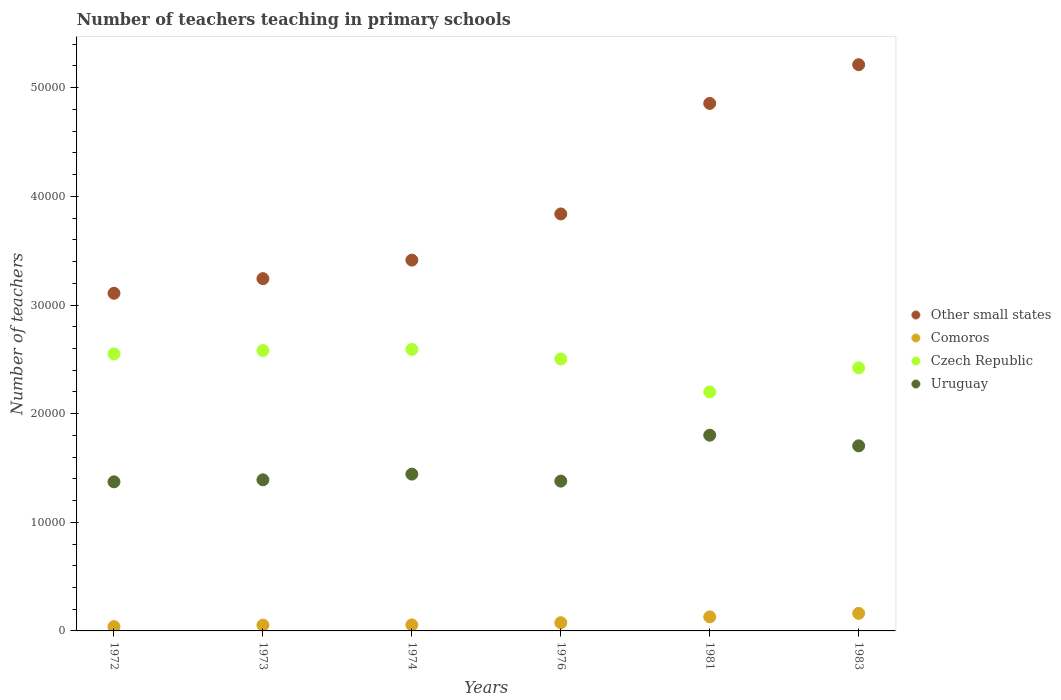Is the number of dotlines equal to the number of legend labels?
Offer a very short reply. Yes. What is the number of teachers teaching in primary schools in Other small states in 1972?
Give a very brief answer. 3.11e+04. Across all years, what is the maximum number of teachers teaching in primary schools in Comoros?
Make the answer very short. 1617. Across all years, what is the minimum number of teachers teaching in primary schools in Czech Republic?
Your answer should be compact. 2.20e+04. In which year was the number of teachers teaching in primary schools in Uruguay maximum?
Offer a very short reply. 1981. In which year was the number of teachers teaching in primary schools in Comoros minimum?
Your response must be concise. 1972. What is the total number of teachers teaching in primary schools in Comoros in the graph?
Your answer should be compact. 5148. What is the difference between the number of teachers teaching in primary schools in Comoros in 1973 and that in 1983?
Give a very brief answer. -1084. What is the difference between the number of teachers teaching in primary schools in Uruguay in 1972 and the number of teachers teaching in primary schools in Comoros in 1976?
Ensure brevity in your answer.  1.30e+04. What is the average number of teachers teaching in primary schools in Comoros per year?
Your response must be concise. 858. In the year 1972, what is the difference between the number of teachers teaching in primary schools in Other small states and number of teachers teaching in primary schools in Czech Republic?
Keep it short and to the point. 5582.75. In how many years, is the number of teachers teaching in primary schools in Uruguay greater than 36000?
Provide a succinct answer. 0. What is the ratio of the number of teachers teaching in primary schools in Comoros in 1976 to that in 1981?
Your answer should be very brief. 0.59. Is the number of teachers teaching in primary schools in Czech Republic in 1972 less than that in 1973?
Keep it short and to the point. Yes. Is the difference between the number of teachers teaching in primary schools in Other small states in 1972 and 1981 greater than the difference between the number of teachers teaching in primary schools in Czech Republic in 1972 and 1981?
Offer a very short reply. No. What is the difference between the highest and the second highest number of teachers teaching in primary schools in Other small states?
Make the answer very short. 3565.71. What is the difference between the highest and the lowest number of teachers teaching in primary schools in Czech Republic?
Your response must be concise. 3914. In how many years, is the number of teachers teaching in primary schools in Other small states greater than the average number of teachers teaching in primary schools in Other small states taken over all years?
Give a very brief answer. 2. Is the sum of the number of teachers teaching in primary schools in Uruguay in 1976 and 1983 greater than the maximum number of teachers teaching in primary schools in Other small states across all years?
Provide a succinct answer. No. Is it the case that in every year, the sum of the number of teachers teaching in primary schools in Czech Republic and number of teachers teaching in primary schools in Other small states  is greater than the number of teachers teaching in primary schools in Uruguay?
Ensure brevity in your answer.  Yes. Is the number of teachers teaching in primary schools in Comoros strictly greater than the number of teachers teaching in primary schools in Other small states over the years?
Offer a very short reply. No. Is the number of teachers teaching in primary schools in Comoros strictly less than the number of teachers teaching in primary schools in Czech Republic over the years?
Offer a very short reply. Yes. Are the values on the major ticks of Y-axis written in scientific E-notation?
Keep it short and to the point. No. Does the graph contain grids?
Keep it short and to the point. No. How many legend labels are there?
Offer a very short reply. 4. What is the title of the graph?
Your response must be concise. Number of teachers teaching in primary schools. Does "Cyprus" appear as one of the legend labels in the graph?
Keep it short and to the point. No. What is the label or title of the Y-axis?
Give a very brief answer. Number of teachers. What is the Number of teachers of Other small states in 1972?
Keep it short and to the point. 3.11e+04. What is the Number of teachers of Comoros in 1972?
Ensure brevity in your answer.  396. What is the Number of teachers of Czech Republic in 1972?
Provide a succinct answer. 2.55e+04. What is the Number of teachers of Uruguay in 1972?
Your answer should be compact. 1.37e+04. What is the Number of teachers in Other small states in 1973?
Keep it short and to the point. 3.24e+04. What is the Number of teachers in Comoros in 1973?
Give a very brief answer. 533. What is the Number of teachers in Czech Republic in 1973?
Offer a terse response. 2.58e+04. What is the Number of teachers in Uruguay in 1973?
Provide a short and direct response. 1.39e+04. What is the Number of teachers in Other small states in 1974?
Your answer should be very brief. 3.41e+04. What is the Number of teachers of Comoros in 1974?
Provide a succinct answer. 554. What is the Number of teachers of Czech Republic in 1974?
Offer a terse response. 2.59e+04. What is the Number of teachers of Uruguay in 1974?
Provide a succinct answer. 1.44e+04. What is the Number of teachers of Other small states in 1976?
Keep it short and to the point. 3.84e+04. What is the Number of teachers in Comoros in 1976?
Your response must be concise. 756. What is the Number of teachers of Czech Republic in 1976?
Offer a terse response. 2.50e+04. What is the Number of teachers in Uruguay in 1976?
Provide a succinct answer. 1.38e+04. What is the Number of teachers in Other small states in 1981?
Offer a very short reply. 4.86e+04. What is the Number of teachers in Comoros in 1981?
Provide a short and direct response. 1292. What is the Number of teachers in Czech Republic in 1981?
Give a very brief answer. 2.20e+04. What is the Number of teachers of Uruguay in 1981?
Offer a very short reply. 1.80e+04. What is the Number of teachers of Other small states in 1983?
Give a very brief answer. 5.21e+04. What is the Number of teachers of Comoros in 1983?
Ensure brevity in your answer.  1617. What is the Number of teachers of Czech Republic in 1983?
Provide a succinct answer. 2.42e+04. What is the Number of teachers in Uruguay in 1983?
Ensure brevity in your answer.  1.70e+04. Across all years, what is the maximum Number of teachers in Other small states?
Ensure brevity in your answer.  5.21e+04. Across all years, what is the maximum Number of teachers in Comoros?
Provide a short and direct response. 1617. Across all years, what is the maximum Number of teachers of Czech Republic?
Your answer should be compact. 2.59e+04. Across all years, what is the maximum Number of teachers in Uruguay?
Offer a very short reply. 1.80e+04. Across all years, what is the minimum Number of teachers of Other small states?
Your answer should be compact. 3.11e+04. Across all years, what is the minimum Number of teachers in Comoros?
Provide a succinct answer. 396. Across all years, what is the minimum Number of teachers in Czech Republic?
Offer a very short reply. 2.20e+04. Across all years, what is the minimum Number of teachers of Uruguay?
Keep it short and to the point. 1.37e+04. What is the total Number of teachers of Other small states in the graph?
Offer a very short reply. 2.37e+05. What is the total Number of teachers of Comoros in the graph?
Provide a short and direct response. 5148. What is the total Number of teachers of Czech Republic in the graph?
Offer a terse response. 1.48e+05. What is the total Number of teachers of Uruguay in the graph?
Offer a terse response. 9.09e+04. What is the difference between the Number of teachers of Other small states in 1972 and that in 1973?
Ensure brevity in your answer.  -1344.78. What is the difference between the Number of teachers in Comoros in 1972 and that in 1973?
Give a very brief answer. -137. What is the difference between the Number of teachers of Czech Republic in 1972 and that in 1973?
Make the answer very short. -311. What is the difference between the Number of teachers in Uruguay in 1972 and that in 1973?
Ensure brevity in your answer.  -184. What is the difference between the Number of teachers in Other small states in 1972 and that in 1974?
Give a very brief answer. -3051.4. What is the difference between the Number of teachers in Comoros in 1972 and that in 1974?
Provide a succinct answer. -158. What is the difference between the Number of teachers in Czech Republic in 1972 and that in 1974?
Offer a very short reply. -415. What is the difference between the Number of teachers of Uruguay in 1972 and that in 1974?
Your answer should be very brief. -710. What is the difference between the Number of teachers in Other small states in 1972 and that in 1976?
Your answer should be compact. -7301.05. What is the difference between the Number of teachers of Comoros in 1972 and that in 1976?
Offer a terse response. -360. What is the difference between the Number of teachers of Czech Republic in 1972 and that in 1976?
Provide a short and direct response. 466. What is the difference between the Number of teachers in Uruguay in 1972 and that in 1976?
Your answer should be compact. -64. What is the difference between the Number of teachers of Other small states in 1972 and that in 1981?
Offer a terse response. -1.75e+04. What is the difference between the Number of teachers of Comoros in 1972 and that in 1981?
Provide a short and direct response. -896. What is the difference between the Number of teachers of Czech Republic in 1972 and that in 1981?
Provide a succinct answer. 3499. What is the difference between the Number of teachers in Uruguay in 1972 and that in 1981?
Give a very brief answer. -4293. What is the difference between the Number of teachers of Other small states in 1972 and that in 1983?
Make the answer very short. -2.10e+04. What is the difference between the Number of teachers in Comoros in 1972 and that in 1983?
Your response must be concise. -1221. What is the difference between the Number of teachers in Czech Republic in 1972 and that in 1983?
Provide a succinct answer. 1282. What is the difference between the Number of teachers in Uruguay in 1972 and that in 1983?
Keep it short and to the point. -3312. What is the difference between the Number of teachers in Other small states in 1973 and that in 1974?
Offer a terse response. -1706.62. What is the difference between the Number of teachers of Comoros in 1973 and that in 1974?
Offer a very short reply. -21. What is the difference between the Number of teachers of Czech Republic in 1973 and that in 1974?
Offer a terse response. -104. What is the difference between the Number of teachers of Uruguay in 1973 and that in 1974?
Your answer should be very brief. -526. What is the difference between the Number of teachers of Other small states in 1973 and that in 1976?
Your answer should be very brief. -5956.27. What is the difference between the Number of teachers of Comoros in 1973 and that in 1976?
Offer a terse response. -223. What is the difference between the Number of teachers in Czech Republic in 1973 and that in 1976?
Your answer should be compact. 777. What is the difference between the Number of teachers in Uruguay in 1973 and that in 1976?
Provide a succinct answer. 120. What is the difference between the Number of teachers in Other small states in 1973 and that in 1981?
Provide a succinct answer. -1.61e+04. What is the difference between the Number of teachers in Comoros in 1973 and that in 1981?
Your answer should be very brief. -759. What is the difference between the Number of teachers of Czech Republic in 1973 and that in 1981?
Your response must be concise. 3810. What is the difference between the Number of teachers in Uruguay in 1973 and that in 1981?
Provide a succinct answer. -4109. What is the difference between the Number of teachers in Other small states in 1973 and that in 1983?
Offer a terse response. -1.97e+04. What is the difference between the Number of teachers of Comoros in 1973 and that in 1983?
Your answer should be compact. -1084. What is the difference between the Number of teachers of Czech Republic in 1973 and that in 1983?
Your answer should be compact. 1593. What is the difference between the Number of teachers of Uruguay in 1973 and that in 1983?
Keep it short and to the point. -3128. What is the difference between the Number of teachers in Other small states in 1974 and that in 1976?
Give a very brief answer. -4249.65. What is the difference between the Number of teachers of Comoros in 1974 and that in 1976?
Your answer should be compact. -202. What is the difference between the Number of teachers in Czech Republic in 1974 and that in 1976?
Offer a very short reply. 881. What is the difference between the Number of teachers of Uruguay in 1974 and that in 1976?
Give a very brief answer. 646. What is the difference between the Number of teachers of Other small states in 1974 and that in 1981?
Offer a terse response. -1.44e+04. What is the difference between the Number of teachers of Comoros in 1974 and that in 1981?
Offer a very short reply. -738. What is the difference between the Number of teachers of Czech Republic in 1974 and that in 1981?
Give a very brief answer. 3914. What is the difference between the Number of teachers of Uruguay in 1974 and that in 1981?
Offer a terse response. -3583. What is the difference between the Number of teachers of Other small states in 1974 and that in 1983?
Offer a very short reply. -1.80e+04. What is the difference between the Number of teachers in Comoros in 1974 and that in 1983?
Provide a short and direct response. -1063. What is the difference between the Number of teachers in Czech Republic in 1974 and that in 1983?
Offer a very short reply. 1697. What is the difference between the Number of teachers in Uruguay in 1974 and that in 1983?
Offer a very short reply. -2602. What is the difference between the Number of teachers in Other small states in 1976 and that in 1981?
Offer a terse response. -1.02e+04. What is the difference between the Number of teachers of Comoros in 1976 and that in 1981?
Give a very brief answer. -536. What is the difference between the Number of teachers in Czech Republic in 1976 and that in 1981?
Provide a short and direct response. 3033. What is the difference between the Number of teachers in Uruguay in 1976 and that in 1981?
Make the answer very short. -4229. What is the difference between the Number of teachers in Other small states in 1976 and that in 1983?
Keep it short and to the point. -1.37e+04. What is the difference between the Number of teachers of Comoros in 1976 and that in 1983?
Keep it short and to the point. -861. What is the difference between the Number of teachers of Czech Republic in 1976 and that in 1983?
Keep it short and to the point. 816. What is the difference between the Number of teachers of Uruguay in 1976 and that in 1983?
Provide a succinct answer. -3248. What is the difference between the Number of teachers of Other small states in 1981 and that in 1983?
Offer a terse response. -3565.71. What is the difference between the Number of teachers of Comoros in 1981 and that in 1983?
Give a very brief answer. -325. What is the difference between the Number of teachers of Czech Republic in 1981 and that in 1983?
Offer a very short reply. -2217. What is the difference between the Number of teachers of Uruguay in 1981 and that in 1983?
Provide a short and direct response. 981. What is the difference between the Number of teachers of Other small states in 1972 and the Number of teachers of Comoros in 1973?
Give a very brief answer. 3.05e+04. What is the difference between the Number of teachers in Other small states in 1972 and the Number of teachers in Czech Republic in 1973?
Give a very brief answer. 5271.75. What is the difference between the Number of teachers of Other small states in 1972 and the Number of teachers of Uruguay in 1973?
Keep it short and to the point. 1.72e+04. What is the difference between the Number of teachers in Comoros in 1972 and the Number of teachers in Czech Republic in 1973?
Your answer should be very brief. -2.54e+04. What is the difference between the Number of teachers in Comoros in 1972 and the Number of teachers in Uruguay in 1973?
Your answer should be compact. -1.35e+04. What is the difference between the Number of teachers in Czech Republic in 1972 and the Number of teachers in Uruguay in 1973?
Offer a very short reply. 1.16e+04. What is the difference between the Number of teachers of Other small states in 1972 and the Number of teachers of Comoros in 1974?
Offer a very short reply. 3.05e+04. What is the difference between the Number of teachers of Other small states in 1972 and the Number of teachers of Czech Republic in 1974?
Your response must be concise. 5167.75. What is the difference between the Number of teachers of Other small states in 1972 and the Number of teachers of Uruguay in 1974?
Your answer should be compact. 1.66e+04. What is the difference between the Number of teachers in Comoros in 1972 and the Number of teachers in Czech Republic in 1974?
Provide a succinct answer. -2.55e+04. What is the difference between the Number of teachers in Comoros in 1972 and the Number of teachers in Uruguay in 1974?
Your answer should be compact. -1.40e+04. What is the difference between the Number of teachers of Czech Republic in 1972 and the Number of teachers of Uruguay in 1974?
Offer a terse response. 1.11e+04. What is the difference between the Number of teachers of Other small states in 1972 and the Number of teachers of Comoros in 1976?
Make the answer very short. 3.03e+04. What is the difference between the Number of teachers in Other small states in 1972 and the Number of teachers in Czech Republic in 1976?
Give a very brief answer. 6048.75. What is the difference between the Number of teachers in Other small states in 1972 and the Number of teachers in Uruguay in 1976?
Your answer should be very brief. 1.73e+04. What is the difference between the Number of teachers of Comoros in 1972 and the Number of teachers of Czech Republic in 1976?
Provide a succinct answer. -2.46e+04. What is the difference between the Number of teachers in Comoros in 1972 and the Number of teachers in Uruguay in 1976?
Your answer should be compact. -1.34e+04. What is the difference between the Number of teachers in Czech Republic in 1972 and the Number of teachers in Uruguay in 1976?
Your response must be concise. 1.17e+04. What is the difference between the Number of teachers of Other small states in 1972 and the Number of teachers of Comoros in 1981?
Offer a terse response. 2.98e+04. What is the difference between the Number of teachers in Other small states in 1972 and the Number of teachers in Czech Republic in 1981?
Offer a terse response. 9081.75. What is the difference between the Number of teachers in Other small states in 1972 and the Number of teachers in Uruguay in 1981?
Offer a terse response. 1.31e+04. What is the difference between the Number of teachers of Comoros in 1972 and the Number of teachers of Czech Republic in 1981?
Ensure brevity in your answer.  -2.16e+04. What is the difference between the Number of teachers of Comoros in 1972 and the Number of teachers of Uruguay in 1981?
Your response must be concise. -1.76e+04. What is the difference between the Number of teachers of Czech Republic in 1972 and the Number of teachers of Uruguay in 1981?
Ensure brevity in your answer.  7481. What is the difference between the Number of teachers in Other small states in 1972 and the Number of teachers in Comoros in 1983?
Give a very brief answer. 2.95e+04. What is the difference between the Number of teachers in Other small states in 1972 and the Number of teachers in Czech Republic in 1983?
Ensure brevity in your answer.  6864.75. What is the difference between the Number of teachers of Other small states in 1972 and the Number of teachers of Uruguay in 1983?
Offer a terse response. 1.40e+04. What is the difference between the Number of teachers in Comoros in 1972 and the Number of teachers in Czech Republic in 1983?
Provide a succinct answer. -2.38e+04. What is the difference between the Number of teachers in Comoros in 1972 and the Number of teachers in Uruguay in 1983?
Make the answer very short. -1.66e+04. What is the difference between the Number of teachers of Czech Republic in 1972 and the Number of teachers of Uruguay in 1983?
Offer a very short reply. 8462. What is the difference between the Number of teachers of Other small states in 1973 and the Number of teachers of Comoros in 1974?
Your answer should be very brief. 3.19e+04. What is the difference between the Number of teachers in Other small states in 1973 and the Number of teachers in Czech Republic in 1974?
Offer a very short reply. 6512.53. What is the difference between the Number of teachers of Other small states in 1973 and the Number of teachers of Uruguay in 1974?
Offer a terse response. 1.80e+04. What is the difference between the Number of teachers of Comoros in 1973 and the Number of teachers of Czech Republic in 1974?
Provide a short and direct response. -2.54e+04. What is the difference between the Number of teachers of Comoros in 1973 and the Number of teachers of Uruguay in 1974?
Your response must be concise. -1.39e+04. What is the difference between the Number of teachers in Czech Republic in 1973 and the Number of teachers in Uruguay in 1974?
Offer a very short reply. 1.14e+04. What is the difference between the Number of teachers of Other small states in 1973 and the Number of teachers of Comoros in 1976?
Provide a short and direct response. 3.17e+04. What is the difference between the Number of teachers in Other small states in 1973 and the Number of teachers in Czech Republic in 1976?
Your answer should be very brief. 7393.53. What is the difference between the Number of teachers in Other small states in 1973 and the Number of teachers in Uruguay in 1976?
Provide a short and direct response. 1.86e+04. What is the difference between the Number of teachers of Comoros in 1973 and the Number of teachers of Czech Republic in 1976?
Your response must be concise. -2.45e+04. What is the difference between the Number of teachers in Comoros in 1973 and the Number of teachers in Uruguay in 1976?
Your response must be concise. -1.33e+04. What is the difference between the Number of teachers of Czech Republic in 1973 and the Number of teachers of Uruguay in 1976?
Your answer should be compact. 1.20e+04. What is the difference between the Number of teachers in Other small states in 1973 and the Number of teachers in Comoros in 1981?
Make the answer very short. 3.11e+04. What is the difference between the Number of teachers of Other small states in 1973 and the Number of teachers of Czech Republic in 1981?
Make the answer very short. 1.04e+04. What is the difference between the Number of teachers in Other small states in 1973 and the Number of teachers in Uruguay in 1981?
Your response must be concise. 1.44e+04. What is the difference between the Number of teachers in Comoros in 1973 and the Number of teachers in Czech Republic in 1981?
Ensure brevity in your answer.  -2.15e+04. What is the difference between the Number of teachers of Comoros in 1973 and the Number of teachers of Uruguay in 1981?
Give a very brief answer. -1.75e+04. What is the difference between the Number of teachers of Czech Republic in 1973 and the Number of teachers of Uruguay in 1981?
Ensure brevity in your answer.  7792. What is the difference between the Number of teachers in Other small states in 1973 and the Number of teachers in Comoros in 1983?
Provide a succinct answer. 3.08e+04. What is the difference between the Number of teachers in Other small states in 1973 and the Number of teachers in Czech Republic in 1983?
Give a very brief answer. 8209.53. What is the difference between the Number of teachers of Other small states in 1973 and the Number of teachers of Uruguay in 1983?
Your response must be concise. 1.54e+04. What is the difference between the Number of teachers of Comoros in 1973 and the Number of teachers of Czech Republic in 1983?
Your answer should be compact. -2.37e+04. What is the difference between the Number of teachers of Comoros in 1973 and the Number of teachers of Uruguay in 1983?
Your answer should be compact. -1.65e+04. What is the difference between the Number of teachers of Czech Republic in 1973 and the Number of teachers of Uruguay in 1983?
Your response must be concise. 8773. What is the difference between the Number of teachers of Other small states in 1974 and the Number of teachers of Comoros in 1976?
Your response must be concise. 3.34e+04. What is the difference between the Number of teachers in Other small states in 1974 and the Number of teachers in Czech Republic in 1976?
Your answer should be very brief. 9100.15. What is the difference between the Number of teachers in Other small states in 1974 and the Number of teachers in Uruguay in 1976?
Offer a terse response. 2.03e+04. What is the difference between the Number of teachers in Comoros in 1974 and the Number of teachers in Czech Republic in 1976?
Provide a succinct answer. -2.45e+04. What is the difference between the Number of teachers of Comoros in 1974 and the Number of teachers of Uruguay in 1976?
Keep it short and to the point. -1.32e+04. What is the difference between the Number of teachers in Czech Republic in 1974 and the Number of teachers in Uruguay in 1976?
Your response must be concise. 1.21e+04. What is the difference between the Number of teachers of Other small states in 1974 and the Number of teachers of Comoros in 1981?
Your response must be concise. 3.28e+04. What is the difference between the Number of teachers of Other small states in 1974 and the Number of teachers of Czech Republic in 1981?
Your answer should be very brief. 1.21e+04. What is the difference between the Number of teachers in Other small states in 1974 and the Number of teachers in Uruguay in 1981?
Offer a very short reply. 1.61e+04. What is the difference between the Number of teachers in Comoros in 1974 and the Number of teachers in Czech Republic in 1981?
Your response must be concise. -2.14e+04. What is the difference between the Number of teachers of Comoros in 1974 and the Number of teachers of Uruguay in 1981?
Make the answer very short. -1.75e+04. What is the difference between the Number of teachers of Czech Republic in 1974 and the Number of teachers of Uruguay in 1981?
Provide a short and direct response. 7896. What is the difference between the Number of teachers in Other small states in 1974 and the Number of teachers in Comoros in 1983?
Offer a terse response. 3.25e+04. What is the difference between the Number of teachers of Other small states in 1974 and the Number of teachers of Czech Republic in 1983?
Ensure brevity in your answer.  9916.15. What is the difference between the Number of teachers in Other small states in 1974 and the Number of teachers in Uruguay in 1983?
Offer a very short reply. 1.71e+04. What is the difference between the Number of teachers of Comoros in 1974 and the Number of teachers of Czech Republic in 1983?
Your answer should be compact. -2.37e+04. What is the difference between the Number of teachers of Comoros in 1974 and the Number of teachers of Uruguay in 1983?
Ensure brevity in your answer.  -1.65e+04. What is the difference between the Number of teachers in Czech Republic in 1974 and the Number of teachers in Uruguay in 1983?
Give a very brief answer. 8877. What is the difference between the Number of teachers of Other small states in 1976 and the Number of teachers of Comoros in 1981?
Your answer should be very brief. 3.71e+04. What is the difference between the Number of teachers of Other small states in 1976 and the Number of teachers of Czech Republic in 1981?
Your answer should be compact. 1.64e+04. What is the difference between the Number of teachers in Other small states in 1976 and the Number of teachers in Uruguay in 1981?
Ensure brevity in your answer.  2.04e+04. What is the difference between the Number of teachers in Comoros in 1976 and the Number of teachers in Czech Republic in 1981?
Offer a terse response. -2.12e+04. What is the difference between the Number of teachers in Comoros in 1976 and the Number of teachers in Uruguay in 1981?
Keep it short and to the point. -1.73e+04. What is the difference between the Number of teachers of Czech Republic in 1976 and the Number of teachers of Uruguay in 1981?
Your answer should be very brief. 7015. What is the difference between the Number of teachers of Other small states in 1976 and the Number of teachers of Comoros in 1983?
Keep it short and to the point. 3.68e+04. What is the difference between the Number of teachers in Other small states in 1976 and the Number of teachers in Czech Republic in 1983?
Offer a very short reply. 1.42e+04. What is the difference between the Number of teachers in Other small states in 1976 and the Number of teachers in Uruguay in 1983?
Make the answer very short. 2.13e+04. What is the difference between the Number of teachers in Comoros in 1976 and the Number of teachers in Czech Republic in 1983?
Your response must be concise. -2.35e+04. What is the difference between the Number of teachers in Comoros in 1976 and the Number of teachers in Uruguay in 1983?
Your answer should be very brief. -1.63e+04. What is the difference between the Number of teachers of Czech Republic in 1976 and the Number of teachers of Uruguay in 1983?
Provide a succinct answer. 7996. What is the difference between the Number of teachers in Other small states in 1981 and the Number of teachers in Comoros in 1983?
Your answer should be very brief. 4.69e+04. What is the difference between the Number of teachers in Other small states in 1981 and the Number of teachers in Czech Republic in 1983?
Give a very brief answer. 2.43e+04. What is the difference between the Number of teachers of Other small states in 1981 and the Number of teachers of Uruguay in 1983?
Offer a very short reply. 3.15e+04. What is the difference between the Number of teachers in Comoros in 1981 and the Number of teachers in Czech Republic in 1983?
Offer a very short reply. -2.29e+04. What is the difference between the Number of teachers of Comoros in 1981 and the Number of teachers of Uruguay in 1983?
Make the answer very short. -1.57e+04. What is the difference between the Number of teachers of Czech Republic in 1981 and the Number of teachers of Uruguay in 1983?
Your answer should be compact. 4963. What is the average Number of teachers in Other small states per year?
Give a very brief answer. 3.94e+04. What is the average Number of teachers in Comoros per year?
Make the answer very short. 858. What is the average Number of teachers in Czech Republic per year?
Your answer should be compact. 2.47e+04. What is the average Number of teachers in Uruguay per year?
Provide a short and direct response. 1.52e+04. In the year 1972, what is the difference between the Number of teachers of Other small states and Number of teachers of Comoros?
Provide a succinct answer. 3.07e+04. In the year 1972, what is the difference between the Number of teachers of Other small states and Number of teachers of Czech Republic?
Give a very brief answer. 5582.75. In the year 1972, what is the difference between the Number of teachers of Other small states and Number of teachers of Uruguay?
Make the answer very short. 1.74e+04. In the year 1972, what is the difference between the Number of teachers of Comoros and Number of teachers of Czech Republic?
Your response must be concise. -2.51e+04. In the year 1972, what is the difference between the Number of teachers of Comoros and Number of teachers of Uruguay?
Provide a succinct answer. -1.33e+04. In the year 1972, what is the difference between the Number of teachers in Czech Republic and Number of teachers in Uruguay?
Your answer should be compact. 1.18e+04. In the year 1973, what is the difference between the Number of teachers of Other small states and Number of teachers of Comoros?
Provide a short and direct response. 3.19e+04. In the year 1973, what is the difference between the Number of teachers in Other small states and Number of teachers in Czech Republic?
Ensure brevity in your answer.  6616.53. In the year 1973, what is the difference between the Number of teachers of Other small states and Number of teachers of Uruguay?
Provide a succinct answer. 1.85e+04. In the year 1973, what is the difference between the Number of teachers in Comoros and Number of teachers in Czech Republic?
Offer a very short reply. -2.53e+04. In the year 1973, what is the difference between the Number of teachers in Comoros and Number of teachers in Uruguay?
Ensure brevity in your answer.  -1.34e+04. In the year 1973, what is the difference between the Number of teachers of Czech Republic and Number of teachers of Uruguay?
Your answer should be very brief. 1.19e+04. In the year 1974, what is the difference between the Number of teachers of Other small states and Number of teachers of Comoros?
Give a very brief answer. 3.36e+04. In the year 1974, what is the difference between the Number of teachers of Other small states and Number of teachers of Czech Republic?
Give a very brief answer. 8219.15. In the year 1974, what is the difference between the Number of teachers in Other small states and Number of teachers in Uruguay?
Provide a succinct answer. 1.97e+04. In the year 1974, what is the difference between the Number of teachers in Comoros and Number of teachers in Czech Republic?
Give a very brief answer. -2.54e+04. In the year 1974, what is the difference between the Number of teachers in Comoros and Number of teachers in Uruguay?
Make the answer very short. -1.39e+04. In the year 1974, what is the difference between the Number of teachers of Czech Republic and Number of teachers of Uruguay?
Make the answer very short. 1.15e+04. In the year 1976, what is the difference between the Number of teachers in Other small states and Number of teachers in Comoros?
Offer a terse response. 3.76e+04. In the year 1976, what is the difference between the Number of teachers of Other small states and Number of teachers of Czech Republic?
Give a very brief answer. 1.33e+04. In the year 1976, what is the difference between the Number of teachers in Other small states and Number of teachers in Uruguay?
Provide a succinct answer. 2.46e+04. In the year 1976, what is the difference between the Number of teachers of Comoros and Number of teachers of Czech Republic?
Provide a succinct answer. -2.43e+04. In the year 1976, what is the difference between the Number of teachers of Comoros and Number of teachers of Uruguay?
Ensure brevity in your answer.  -1.30e+04. In the year 1976, what is the difference between the Number of teachers of Czech Republic and Number of teachers of Uruguay?
Keep it short and to the point. 1.12e+04. In the year 1981, what is the difference between the Number of teachers in Other small states and Number of teachers in Comoros?
Provide a short and direct response. 4.73e+04. In the year 1981, what is the difference between the Number of teachers of Other small states and Number of teachers of Czech Republic?
Provide a short and direct response. 2.66e+04. In the year 1981, what is the difference between the Number of teachers in Other small states and Number of teachers in Uruguay?
Give a very brief answer. 3.05e+04. In the year 1981, what is the difference between the Number of teachers in Comoros and Number of teachers in Czech Republic?
Make the answer very short. -2.07e+04. In the year 1981, what is the difference between the Number of teachers in Comoros and Number of teachers in Uruguay?
Offer a very short reply. -1.67e+04. In the year 1981, what is the difference between the Number of teachers of Czech Republic and Number of teachers of Uruguay?
Ensure brevity in your answer.  3982. In the year 1983, what is the difference between the Number of teachers in Other small states and Number of teachers in Comoros?
Give a very brief answer. 5.05e+04. In the year 1983, what is the difference between the Number of teachers in Other small states and Number of teachers in Czech Republic?
Your response must be concise. 2.79e+04. In the year 1983, what is the difference between the Number of teachers in Other small states and Number of teachers in Uruguay?
Give a very brief answer. 3.51e+04. In the year 1983, what is the difference between the Number of teachers in Comoros and Number of teachers in Czech Republic?
Keep it short and to the point. -2.26e+04. In the year 1983, what is the difference between the Number of teachers in Comoros and Number of teachers in Uruguay?
Ensure brevity in your answer.  -1.54e+04. In the year 1983, what is the difference between the Number of teachers in Czech Republic and Number of teachers in Uruguay?
Your answer should be compact. 7180. What is the ratio of the Number of teachers in Other small states in 1972 to that in 1973?
Offer a terse response. 0.96. What is the ratio of the Number of teachers in Comoros in 1972 to that in 1973?
Your response must be concise. 0.74. What is the ratio of the Number of teachers of Czech Republic in 1972 to that in 1973?
Your response must be concise. 0.99. What is the ratio of the Number of teachers in Other small states in 1972 to that in 1974?
Ensure brevity in your answer.  0.91. What is the ratio of the Number of teachers in Comoros in 1972 to that in 1974?
Make the answer very short. 0.71. What is the ratio of the Number of teachers in Uruguay in 1972 to that in 1974?
Keep it short and to the point. 0.95. What is the ratio of the Number of teachers of Other small states in 1972 to that in 1976?
Ensure brevity in your answer.  0.81. What is the ratio of the Number of teachers of Comoros in 1972 to that in 1976?
Offer a terse response. 0.52. What is the ratio of the Number of teachers in Czech Republic in 1972 to that in 1976?
Offer a terse response. 1.02. What is the ratio of the Number of teachers in Other small states in 1972 to that in 1981?
Ensure brevity in your answer.  0.64. What is the ratio of the Number of teachers of Comoros in 1972 to that in 1981?
Provide a short and direct response. 0.31. What is the ratio of the Number of teachers of Czech Republic in 1972 to that in 1981?
Your answer should be very brief. 1.16. What is the ratio of the Number of teachers of Uruguay in 1972 to that in 1981?
Provide a succinct answer. 0.76. What is the ratio of the Number of teachers of Other small states in 1972 to that in 1983?
Your answer should be very brief. 0.6. What is the ratio of the Number of teachers of Comoros in 1972 to that in 1983?
Offer a very short reply. 0.24. What is the ratio of the Number of teachers in Czech Republic in 1972 to that in 1983?
Make the answer very short. 1.05. What is the ratio of the Number of teachers of Uruguay in 1972 to that in 1983?
Provide a succinct answer. 0.81. What is the ratio of the Number of teachers of Comoros in 1973 to that in 1974?
Your answer should be compact. 0.96. What is the ratio of the Number of teachers in Czech Republic in 1973 to that in 1974?
Provide a succinct answer. 1. What is the ratio of the Number of teachers in Uruguay in 1973 to that in 1974?
Provide a short and direct response. 0.96. What is the ratio of the Number of teachers in Other small states in 1973 to that in 1976?
Your answer should be compact. 0.84. What is the ratio of the Number of teachers of Comoros in 1973 to that in 1976?
Offer a terse response. 0.7. What is the ratio of the Number of teachers of Czech Republic in 1973 to that in 1976?
Your response must be concise. 1.03. What is the ratio of the Number of teachers of Uruguay in 1973 to that in 1976?
Your response must be concise. 1.01. What is the ratio of the Number of teachers of Other small states in 1973 to that in 1981?
Offer a terse response. 0.67. What is the ratio of the Number of teachers of Comoros in 1973 to that in 1981?
Your answer should be very brief. 0.41. What is the ratio of the Number of teachers in Czech Republic in 1973 to that in 1981?
Offer a very short reply. 1.17. What is the ratio of the Number of teachers in Uruguay in 1973 to that in 1981?
Offer a very short reply. 0.77. What is the ratio of the Number of teachers of Other small states in 1973 to that in 1983?
Your answer should be very brief. 0.62. What is the ratio of the Number of teachers of Comoros in 1973 to that in 1983?
Ensure brevity in your answer.  0.33. What is the ratio of the Number of teachers of Czech Republic in 1973 to that in 1983?
Ensure brevity in your answer.  1.07. What is the ratio of the Number of teachers in Uruguay in 1973 to that in 1983?
Your response must be concise. 0.82. What is the ratio of the Number of teachers of Other small states in 1974 to that in 1976?
Keep it short and to the point. 0.89. What is the ratio of the Number of teachers in Comoros in 1974 to that in 1976?
Offer a very short reply. 0.73. What is the ratio of the Number of teachers of Czech Republic in 1974 to that in 1976?
Your answer should be very brief. 1.04. What is the ratio of the Number of teachers in Uruguay in 1974 to that in 1976?
Make the answer very short. 1.05. What is the ratio of the Number of teachers in Other small states in 1974 to that in 1981?
Ensure brevity in your answer.  0.7. What is the ratio of the Number of teachers in Comoros in 1974 to that in 1981?
Provide a succinct answer. 0.43. What is the ratio of the Number of teachers in Czech Republic in 1974 to that in 1981?
Give a very brief answer. 1.18. What is the ratio of the Number of teachers of Uruguay in 1974 to that in 1981?
Give a very brief answer. 0.8. What is the ratio of the Number of teachers of Other small states in 1974 to that in 1983?
Keep it short and to the point. 0.65. What is the ratio of the Number of teachers in Comoros in 1974 to that in 1983?
Your answer should be very brief. 0.34. What is the ratio of the Number of teachers in Czech Republic in 1974 to that in 1983?
Make the answer very short. 1.07. What is the ratio of the Number of teachers of Uruguay in 1974 to that in 1983?
Your response must be concise. 0.85. What is the ratio of the Number of teachers of Other small states in 1976 to that in 1981?
Give a very brief answer. 0.79. What is the ratio of the Number of teachers in Comoros in 1976 to that in 1981?
Keep it short and to the point. 0.59. What is the ratio of the Number of teachers in Czech Republic in 1976 to that in 1981?
Your response must be concise. 1.14. What is the ratio of the Number of teachers of Uruguay in 1976 to that in 1981?
Keep it short and to the point. 0.77. What is the ratio of the Number of teachers in Other small states in 1976 to that in 1983?
Your answer should be compact. 0.74. What is the ratio of the Number of teachers of Comoros in 1976 to that in 1983?
Your answer should be very brief. 0.47. What is the ratio of the Number of teachers of Czech Republic in 1976 to that in 1983?
Provide a succinct answer. 1.03. What is the ratio of the Number of teachers in Uruguay in 1976 to that in 1983?
Offer a terse response. 0.81. What is the ratio of the Number of teachers in Other small states in 1981 to that in 1983?
Provide a succinct answer. 0.93. What is the ratio of the Number of teachers of Comoros in 1981 to that in 1983?
Ensure brevity in your answer.  0.8. What is the ratio of the Number of teachers in Czech Republic in 1981 to that in 1983?
Keep it short and to the point. 0.91. What is the ratio of the Number of teachers in Uruguay in 1981 to that in 1983?
Make the answer very short. 1.06. What is the difference between the highest and the second highest Number of teachers of Other small states?
Offer a terse response. 3565.71. What is the difference between the highest and the second highest Number of teachers of Comoros?
Ensure brevity in your answer.  325. What is the difference between the highest and the second highest Number of teachers of Czech Republic?
Offer a terse response. 104. What is the difference between the highest and the second highest Number of teachers of Uruguay?
Your answer should be compact. 981. What is the difference between the highest and the lowest Number of teachers of Other small states?
Your answer should be very brief. 2.10e+04. What is the difference between the highest and the lowest Number of teachers of Comoros?
Your answer should be very brief. 1221. What is the difference between the highest and the lowest Number of teachers in Czech Republic?
Give a very brief answer. 3914. What is the difference between the highest and the lowest Number of teachers in Uruguay?
Provide a short and direct response. 4293. 